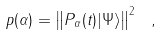Convert formula to latex. <formula><loc_0><loc_0><loc_500><loc_500>p ( \alpha ) = \left \| P _ { \alpha } ( t ) | \Psi \rangle \right \| ^ { 2 } \ ,</formula> 